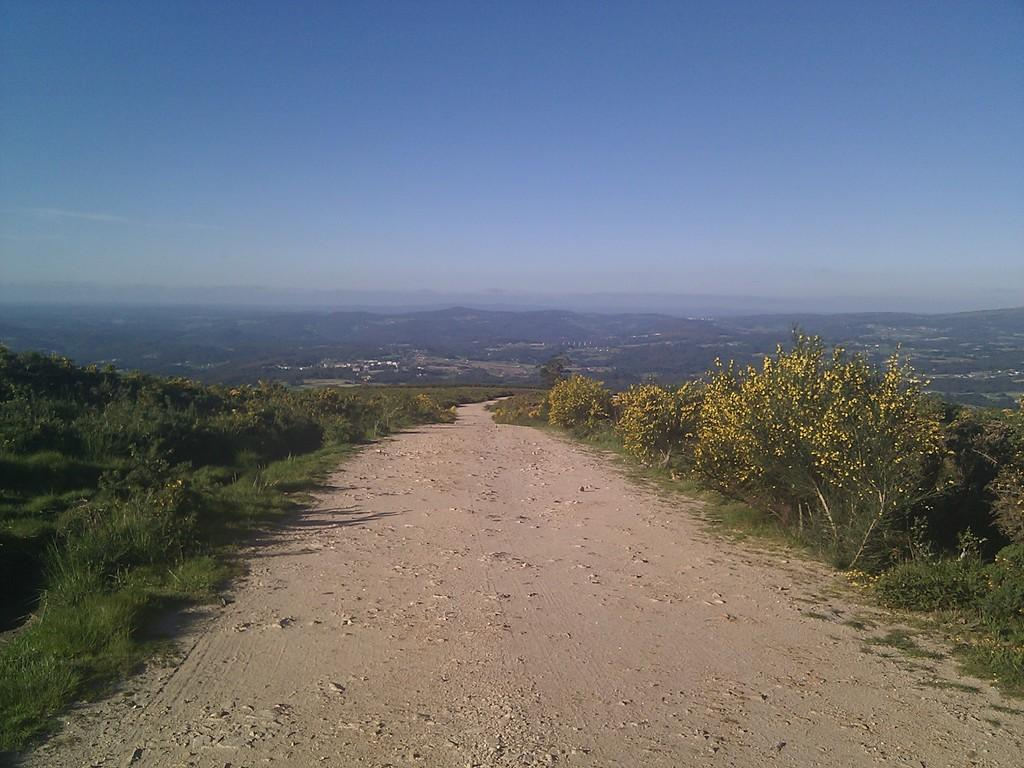What type of surface can be seen in the image? Ground is visible in the image. What type of vegetation is present on the ground? Grass, plants, trees, and flowers are visible in the image. What can be seen in the background of the image? The sky is visible in the background of the image. What is the opinion of the rabbit about the flowers in the image? There is no rabbit present in the image, so it is not possible to determine its opinion about the flowers. 